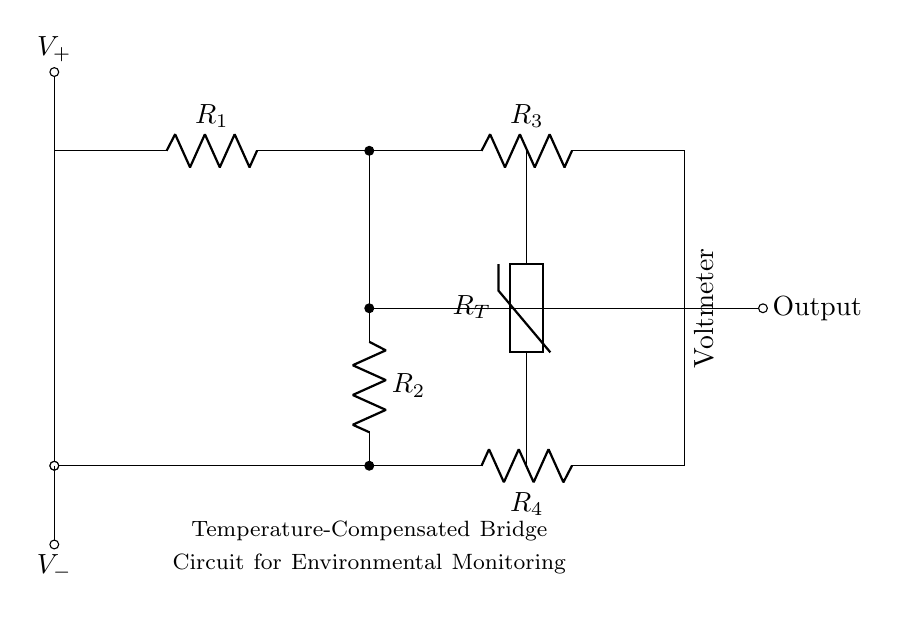What type of circuit is this? This is a bridge circuit, which is characterized by a configuration that compares two or more paths in a circuit to measure a voltage difference. This specific configuration is often used for sensing purposes, like temperature monitoring.
Answer: Bridge circuit What component is denoted by R_T? R_T represents a thermistor, which is a temperature-sensitive resistor that changes its resistance based on the temperature. Its inclusion indicates a focus on thermal measurement in the circuit design.
Answer: Thermistor How many resistors are present in the circuit? There are four resistors in the circuit labeled R_1, R_2, R_3, and R_4. The presence of multiple resistors is typical in a bridge circuit to balance the different arms of the bridge for accurate measurements.
Answer: Four What does the output node represent? The output node is where the voltage measurement is taken relative to the setup of the bridge circuit. It indicates the difference in potential that results from the balance of the resistors and the thermistor, often used for analysis in monitoring applications.
Answer: Output What is the function of the voltage source here? The voltage source, indicated by V_plus and V_minus, provides the necessary power to the circuit. It establishes the voltage levels that allow the bridge circuit to function by enabling the comparison of voltage drops across its components.
Answer: Power supply What role do R_3 and R_4 play in this circuit? R_3 and R_4 function as part of the bridge to achieve balance; they are typically used to set a reference level. Their resistances adjust to compensate for the temperature variations sensed by the thermistor, which helps stabilize the output signal for accurate environmental monitoring.
Answer: Balancing function What does the voltmeter measure in this circuit? The voltmeter measures the voltage difference across the bridge's output node. This measurement reflects changes due to variations in temperature, as indicated by the thermistor's behavior, making the voltmeter essential for environmental monitoring tasks.
Answer: Voltage difference 